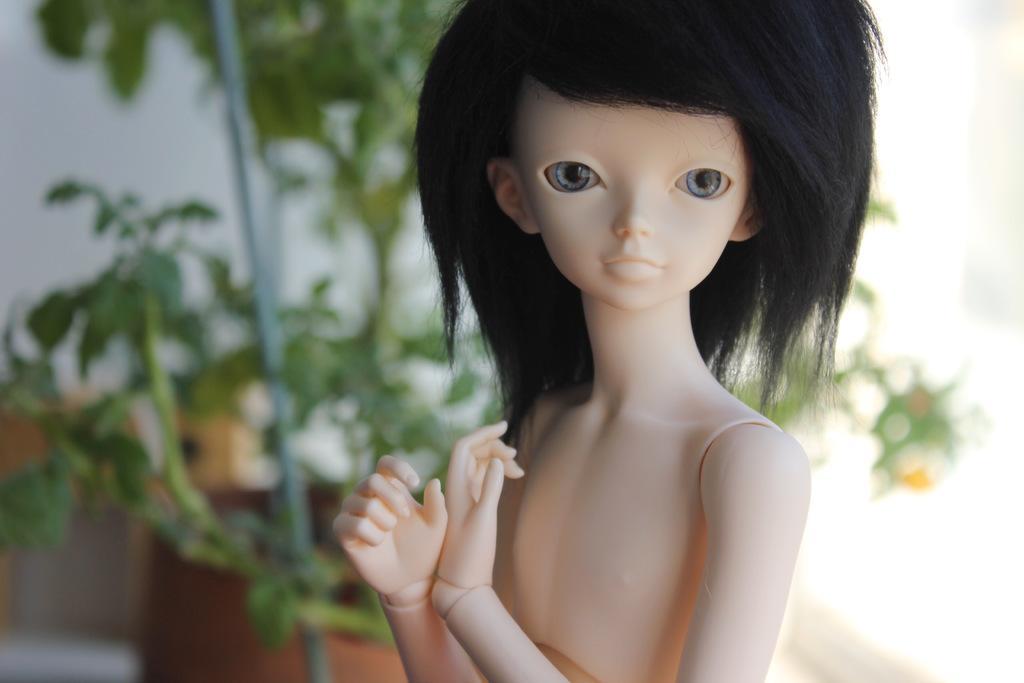How would you summarize this image in a sentence or two? In this image we can see doll. In the background there are plants and wall. 